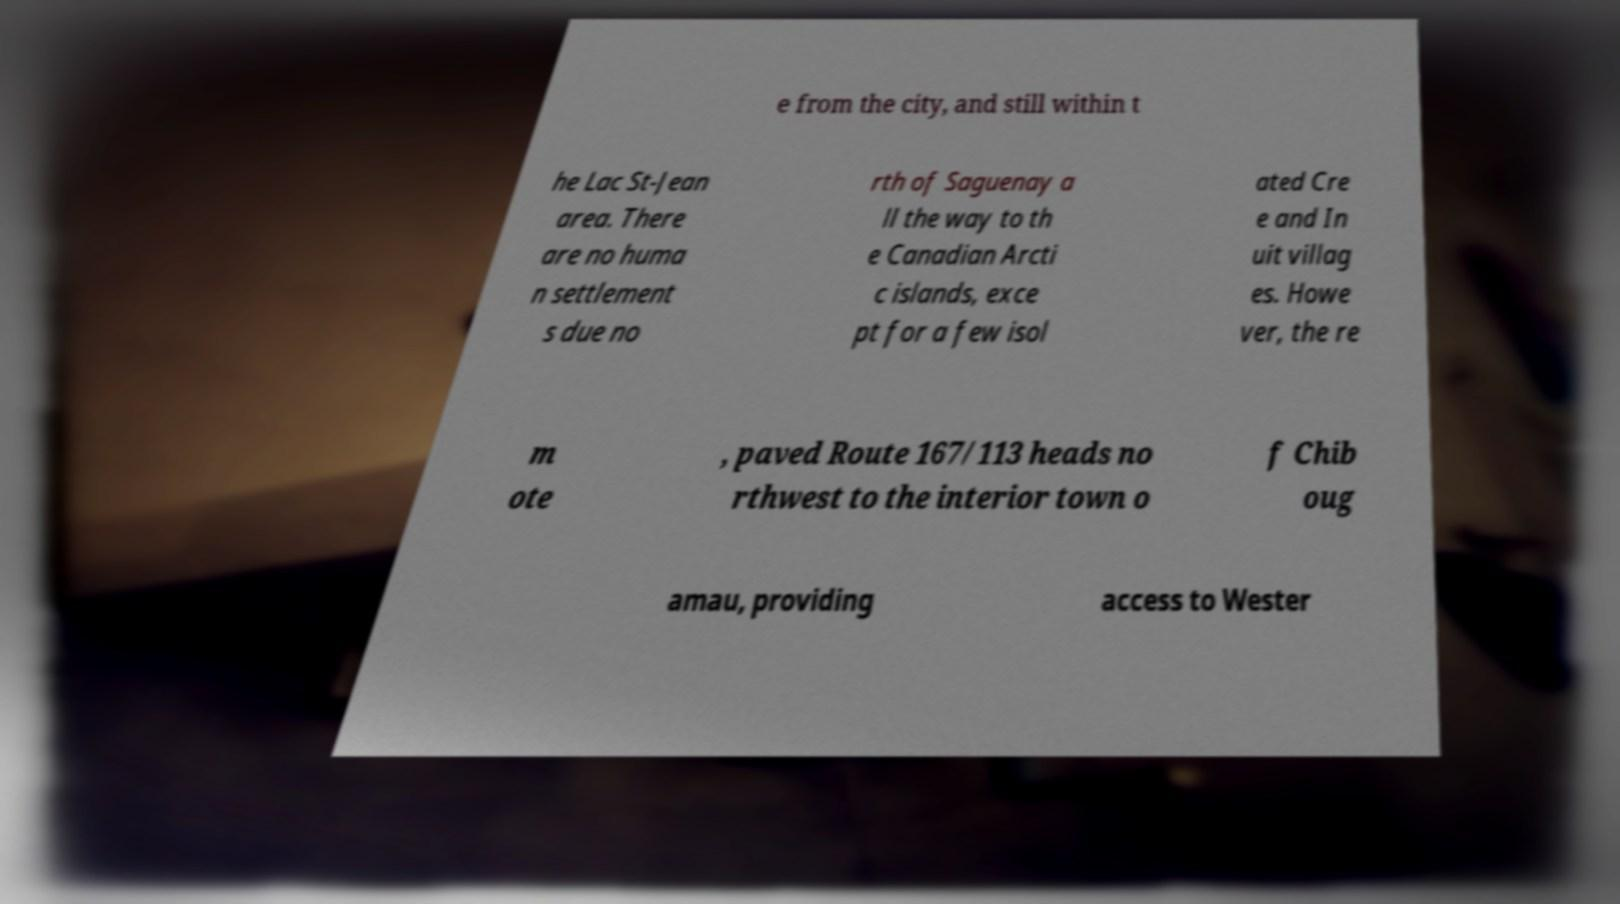There's text embedded in this image that I need extracted. Can you transcribe it verbatim? e from the city, and still within t he Lac St-Jean area. There are no huma n settlement s due no rth of Saguenay a ll the way to th e Canadian Arcti c islands, exce pt for a few isol ated Cre e and In uit villag es. Howe ver, the re m ote , paved Route 167/113 heads no rthwest to the interior town o f Chib oug amau, providing access to Wester 